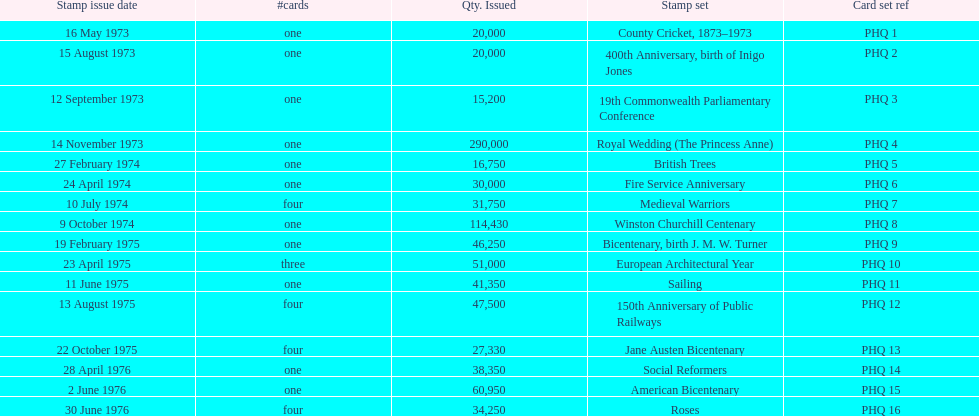List each bicentenary stamp set Bicentenary, birth J. M. W. Turner, Jane Austen Bicentenary, American Bicentenary. 